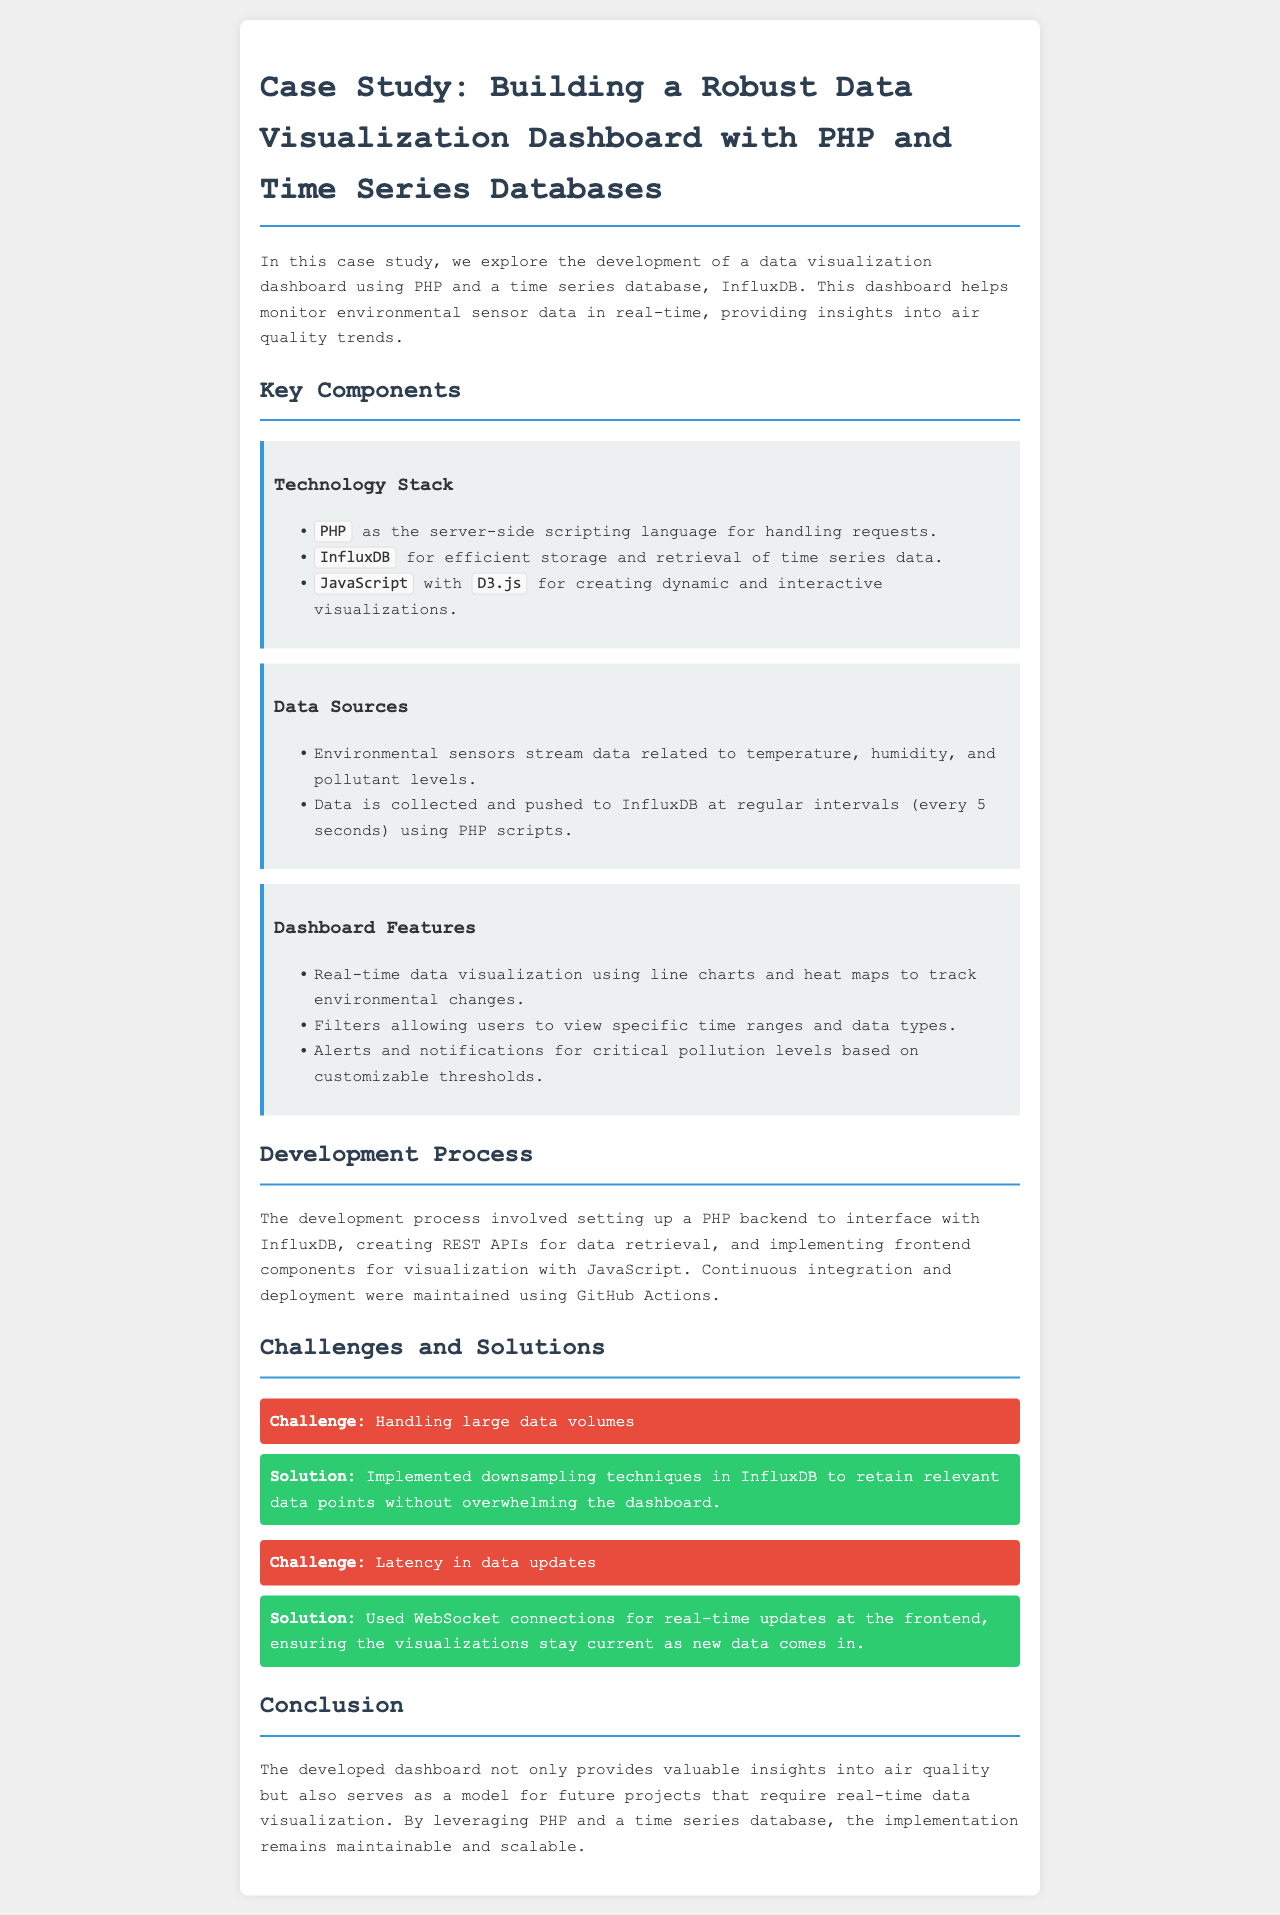What technology stack is used for the dashboard? The technology stack is listed under "Key Components," including PHP, InfluxDB, and D3.js for visualization.
Answer: PHP, InfluxDB, D3.js How often is data pushed to InfluxDB? The document states that data is collected and pushed to InfluxDB at regular intervals every 5 seconds.
Answer: Every 5 seconds What is the main purpose of the dashboard? The purpose is provided in the introduction, which highlights monitoring environmental sensor data in real-time.
Answer: Monitor environmental sensor data What challenge was faced regarding data volumes? The document mentions a challenge specifically related to handling large data volumes while building the dashboard.
Answer: Handling large data volumes What solution was implemented for latency in data updates? The solution mentioned for latency is the use of WebSocket connections for real-time updates at the frontend.
Answer: WebSocket connections What chart types are used for data visualization on the dashboard? The dashboard features real-time data visualization using line charts and heat maps.
Answer: Line charts and heat maps What is the role of GitHub Actions in the development process? The document describes GitHub Actions as a tool for maintaining continuous integration and deployment throughout the development.
Answer: Continuous integration and deployment Which language is primarily used on the server side? The document indicates that PHP is the server-side scripting language utilized for handling requests.
Answer: PHP 